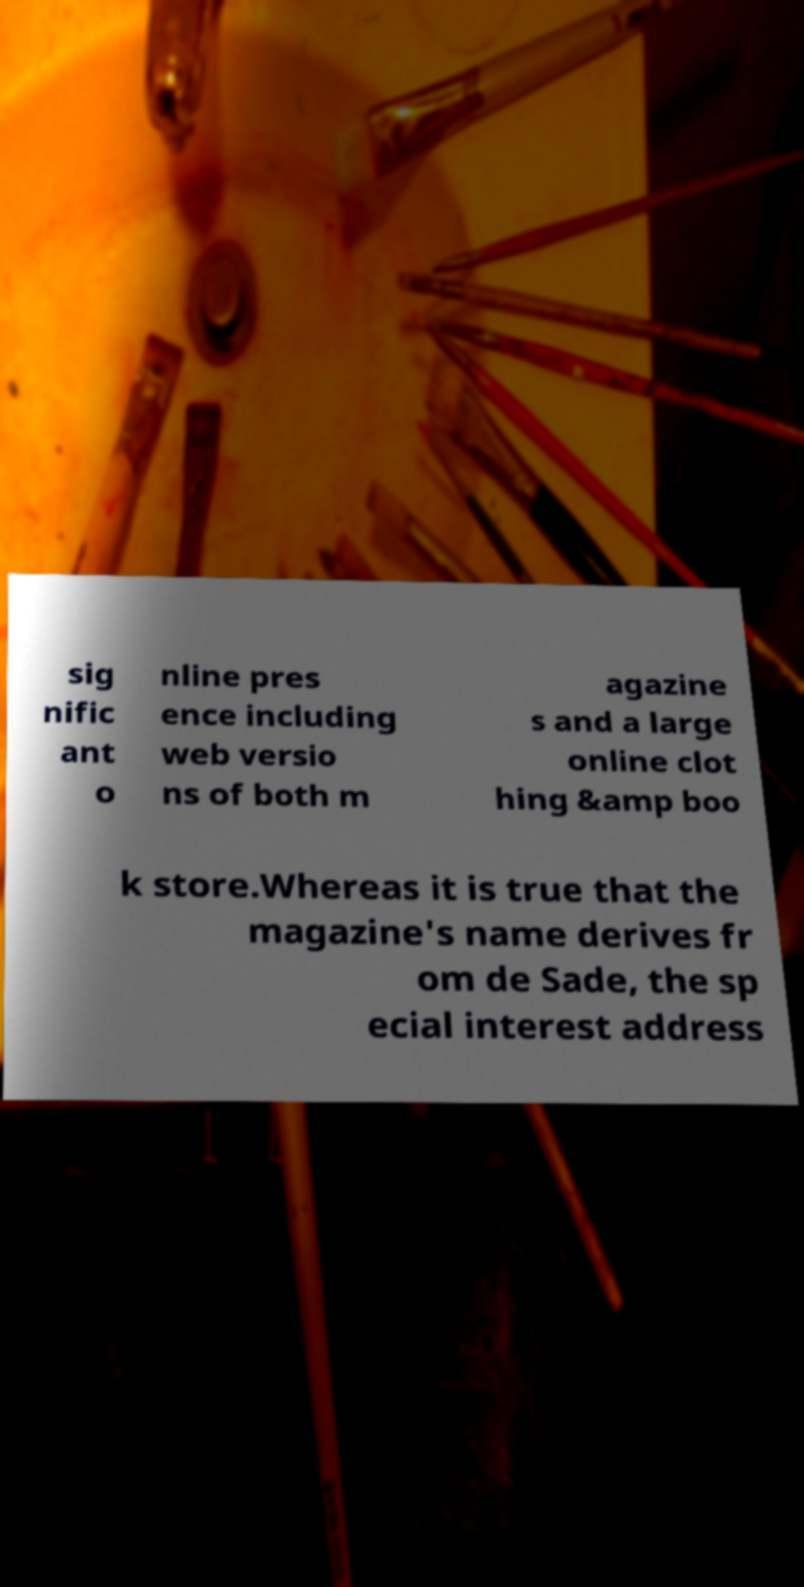Can you accurately transcribe the text from the provided image for me? sig nific ant o nline pres ence including web versio ns of both m agazine s and a large online clot hing &amp boo k store.Whereas it is true that the magazine's name derives fr om de Sade, the sp ecial interest address 